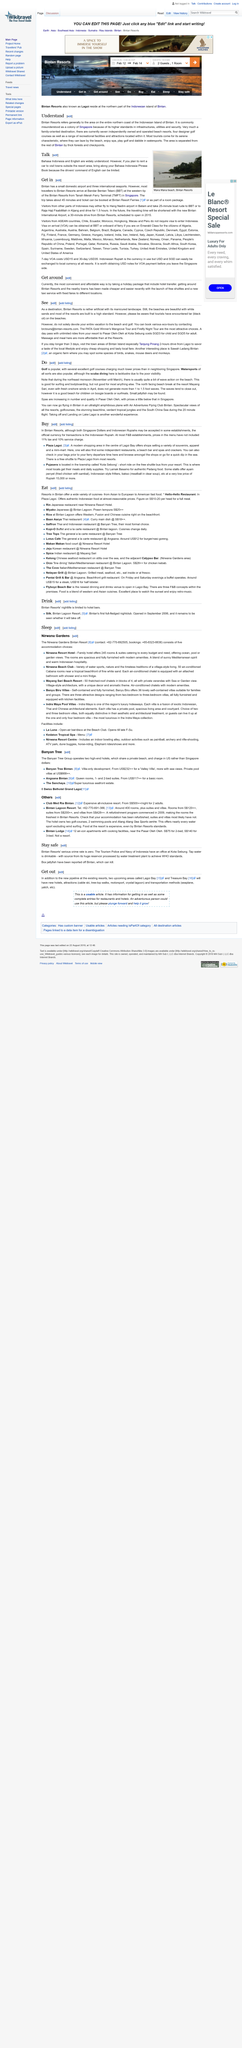Give some essential details in this illustration. Tourists have discovered tar, a black and sticky substance, on the beaches of Bintan Resort, indicating a potentially hazardous situation. The Bintan Resorts are built to a high standard, and this standard is considered the industry standard for resort development. Mana Mana beach is located in Bintan Resorts. Watersports are popular according to Do. Bintan has three international seaports, and these ports are used for international trade and commerce. 